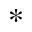Convert formula to latex. <formula><loc_0><loc_0><loc_500><loc_500>^ { * }</formula> 